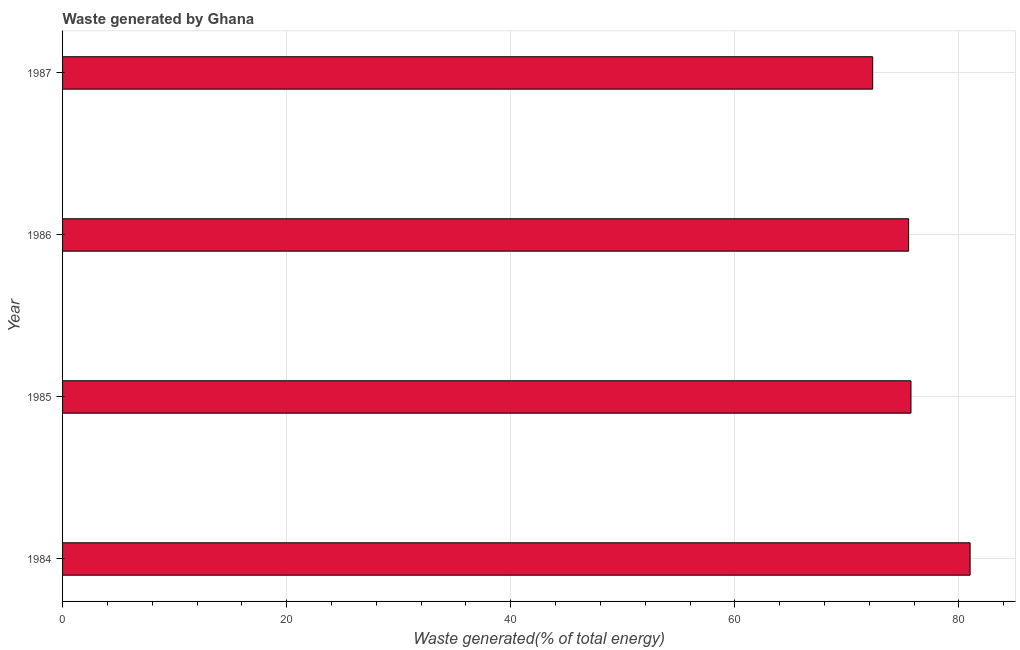Does the graph contain grids?
Your response must be concise. Yes. What is the title of the graph?
Offer a terse response. Waste generated by Ghana. What is the label or title of the X-axis?
Provide a short and direct response. Waste generated(% of total energy). What is the label or title of the Y-axis?
Make the answer very short. Year. What is the amount of waste generated in 1984?
Give a very brief answer. 81. Across all years, what is the maximum amount of waste generated?
Your answer should be compact. 81. Across all years, what is the minimum amount of waste generated?
Offer a terse response. 72.3. In which year was the amount of waste generated maximum?
Keep it short and to the point. 1984. In which year was the amount of waste generated minimum?
Ensure brevity in your answer.  1987. What is the sum of the amount of waste generated?
Your answer should be very brief. 304.52. What is the difference between the amount of waste generated in 1984 and 1986?
Provide a succinct answer. 5.49. What is the average amount of waste generated per year?
Offer a very short reply. 76.13. What is the median amount of waste generated?
Your answer should be compact. 75.61. In how many years, is the amount of waste generated greater than 72 %?
Ensure brevity in your answer.  4. Do a majority of the years between 1987 and 1984 (inclusive) have amount of waste generated greater than 56 %?
Keep it short and to the point. Yes. What is the ratio of the amount of waste generated in 1986 to that in 1987?
Make the answer very short. 1.04. What is the difference between the highest and the second highest amount of waste generated?
Make the answer very short. 5.28. Is the sum of the amount of waste generated in 1985 and 1987 greater than the maximum amount of waste generated across all years?
Keep it short and to the point. Yes. In how many years, is the amount of waste generated greater than the average amount of waste generated taken over all years?
Provide a succinct answer. 1. Are all the bars in the graph horizontal?
Provide a succinct answer. Yes. What is the difference between two consecutive major ticks on the X-axis?
Provide a succinct answer. 20. Are the values on the major ticks of X-axis written in scientific E-notation?
Give a very brief answer. No. What is the Waste generated(% of total energy) in 1984?
Give a very brief answer. 81. What is the Waste generated(% of total energy) in 1985?
Provide a succinct answer. 75.72. What is the Waste generated(% of total energy) in 1986?
Ensure brevity in your answer.  75.51. What is the Waste generated(% of total energy) in 1987?
Give a very brief answer. 72.3. What is the difference between the Waste generated(% of total energy) in 1984 and 1985?
Your answer should be very brief. 5.28. What is the difference between the Waste generated(% of total energy) in 1984 and 1986?
Ensure brevity in your answer.  5.49. What is the difference between the Waste generated(% of total energy) in 1984 and 1987?
Make the answer very short. 8.7. What is the difference between the Waste generated(% of total energy) in 1985 and 1986?
Keep it short and to the point. 0.21. What is the difference between the Waste generated(% of total energy) in 1985 and 1987?
Offer a terse response. 3.42. What is the difference between the Waste generated(% of total energy) in 1986 and 1987?
Your answer should be very brief. 3.21. What is the ratio of the Waste generated(% of total energy) in 1984 to that in 1985?
Your answer should be compact. 1.07. What is the ratio of the Waste generated(% of total energy) in 1984 to that in 1986?
Ensure brevity in your answer.  1.07. What is the ratio of the Waste generated(% of total energy) in 1984 to that in 1987?
Provide a short and direct response. 1.12. What is the ratio of the Waste generated(% of total energy) in 1985 to that in 1987?
Offer a very short reply. 1.05. What is the ratio of the Waste generated(% of total energy) in 1986 to that in 1987?
Offer a terse response. 1.04. 